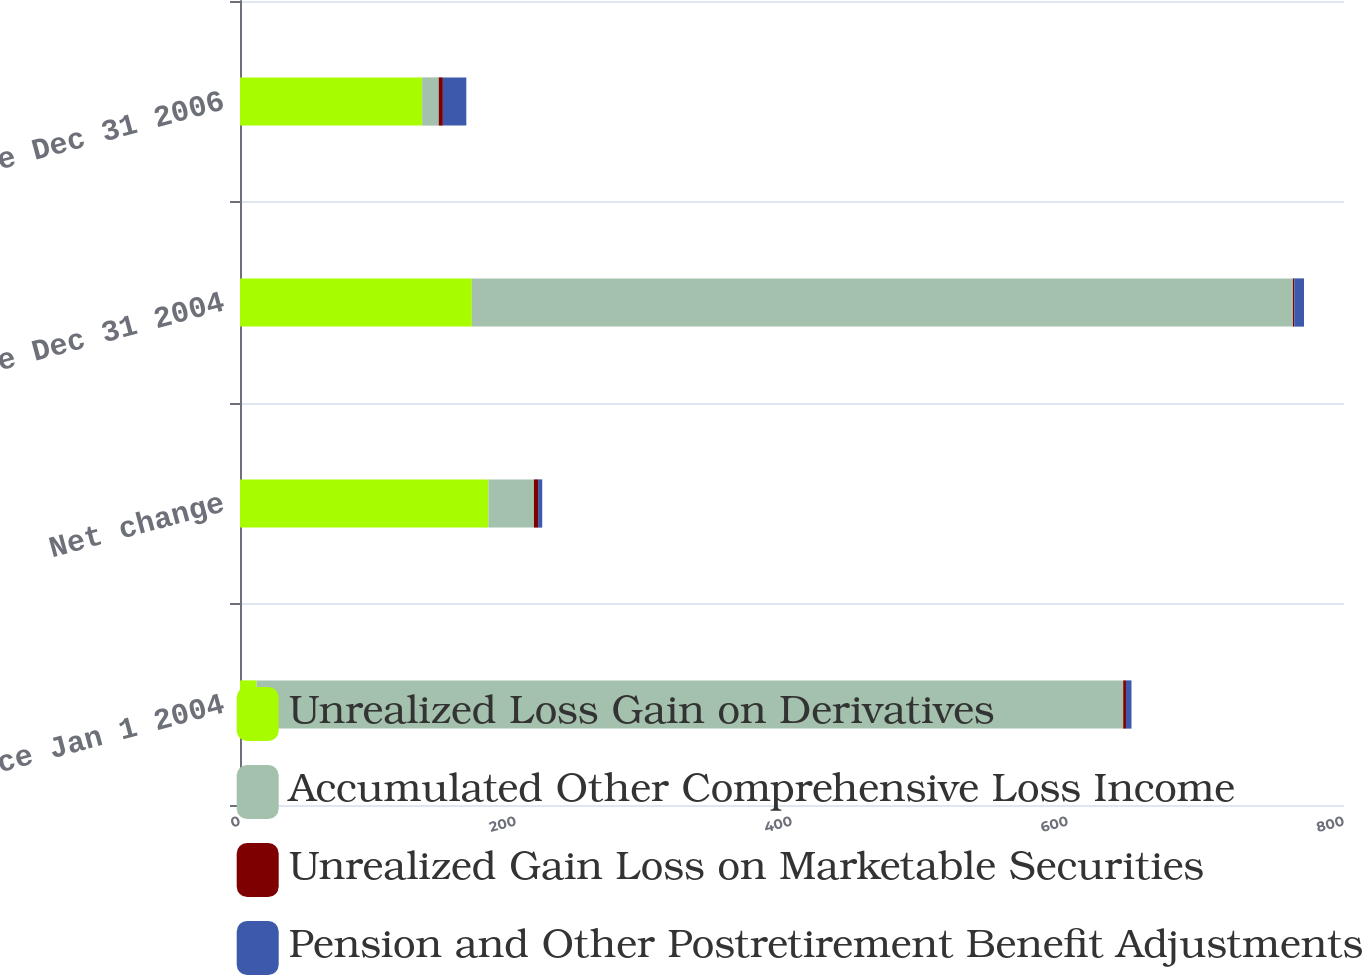Convert chart. <chart><loc_0><loc_0><loc_500><loc_500><stacked_bar_chart><ecel><fcel>Balance Jan 1 2004<fcel>Net change<fcel>Balance Dec 31 2004<fcel>Balance Dec 31 2006<nl><fcel>Unrealized Loss Gain on Derivatives<fcel>12<fcel>180<fcel>168<fcel>132<nl><fcel>Accumulated Other Comprehensive Loss Income<fcel>628<fcel>33<fcel>595<fcel>12<nl><fcel>Unrealized Gain Loss on Marketable Securities<fcel>2<fcel>3<fcel>1<fcel>3<nl><fcel>Pension and Other Postretirement Benefit Adjustments<fcel>4<fcel>3<fcel>7<fcel>17<nl></chart> 